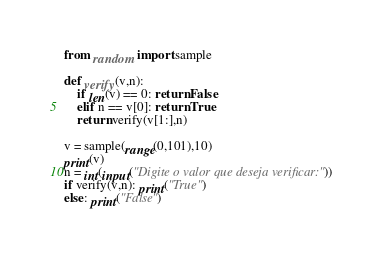Convert code to text. <code><loc_0><loc_0><loc_500><loc_500><_Python_>from random import sample

def verify(v,n):
    if len(v) == 0: return False
    elif n == v[0]: return True
    return verify(v[1:],n)

v = sample(range(0,101),10)
print(v)
n = int(input("Digite o valor que deseja verificar: "))
if verify(v,n): print("True")
else: print("False")



</code> 